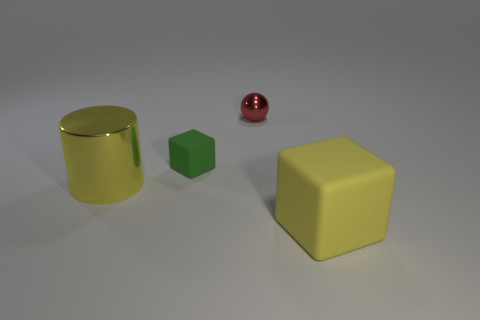Is there any other thing that is the same size as the red shiny ball?
Your response must be concise. Yes. What is the size of the matte block in front of the large yellow object to the left of the tiny metal thing?
Your answer should be very brief. Large. What number of cubes are yellow rubber things or green matte things?
Ensure brevity in your answer.  2. Are there any large cyan metallic objects that have the same shape as the tiny red object?
Ensure brevity in your answer.  No. What is the shape of the green matte object?
Your response must be concise. Cube. How many objects are matte blocks or cylinders?
Ensure brevity in your answer.  3. Is the size of the matte block that is on the left side of the red thing the same as the metal object that is to the right of the tiny rubber object?
Keep it short and to the point. Yes. How many other objects are the same material as the yellow cube?
Ensure brevity in your answer.  1. Is the number of large yellow metal cylinders on the left side of the green rubber block greater than the number of large metal cylinders that are right of the small metallic thing?
Your answer should be very brief. Yes. What is the cube that is behind the yellow cylinder made of?
Your response must be concise. Rubber. 